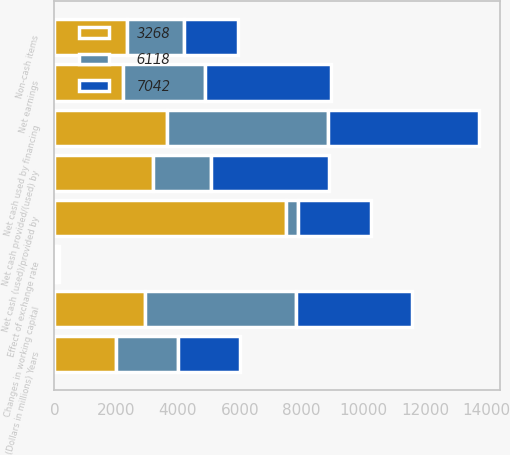<chart> <loc_0><loc_0><loc_500><loc_500><stacked_bar_chart><ecel><fcel>(Dollars in millions) Years<fcel>Net earnings<fcel>Non-cash items<fcel>Changes in working capital<fcel>Net cash (used)/provided by<fcel>Net cash provided/(used) by<fcel>Net cash used by financing<fcel>Effect of exchange rate<nl><fcel>6118<fcel>2008<fcel>2672<fcel>1829<fcel>4902<fcel>401<fcel>1888<fcel>5202<fcel>59<nl><fcel>7042<fcel>2007<fcel>4074<fcel>1753<fcel>3757<fcel>2351<fcel>3822<fcel>4884<fcel>46<nl><fcel>3268<fcel>2006<fcel>2215<fcel>2351<fcel>2933<fcel>7499<fcel>3186<fcel>3645<fcel>38<nl></chart> 